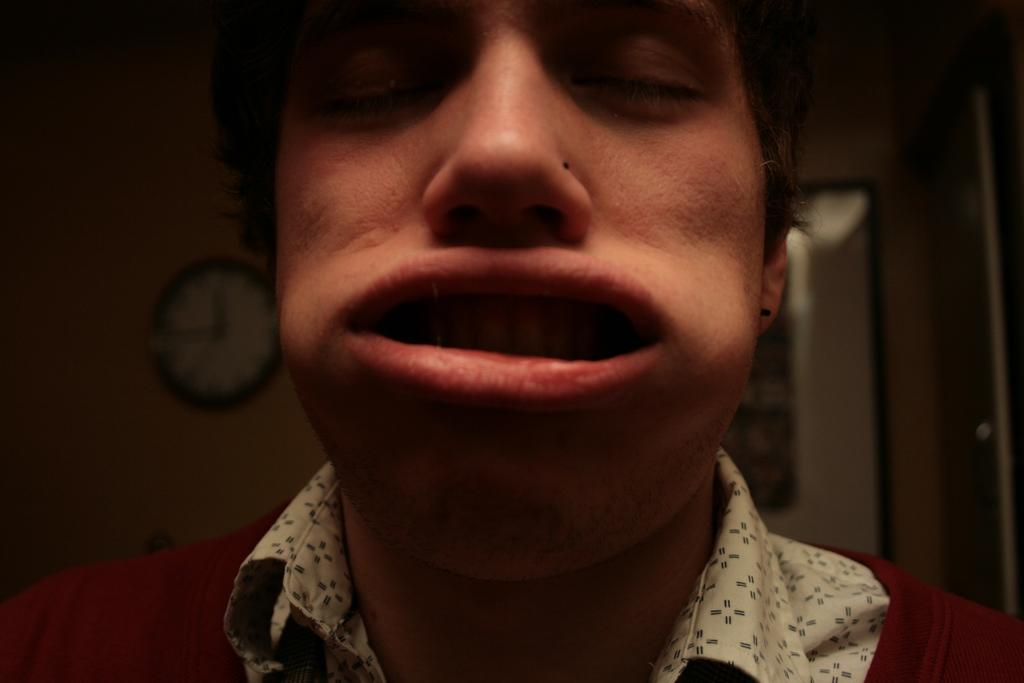What is the main subject of the image? There is a person in the image. What is the person doing in the image? The person is closing their eyes and has a weird expression. What can be seen on the wall in the background? There is a clock on the wall in the background. How would you describe the color of the background in the image? The background is dark in color. What story is the middle thing in the image telling? There is no middle thing in the image, and therefore no story can be associated with it. 